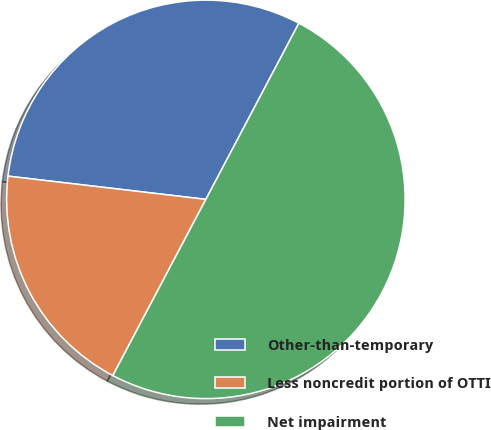Convert chart to OTSL. <chart><loc_0><loc_0><loc_500><loc_500><pie_chart><fcel>Other-than-temporary<fcel>Less noncredit portion of OTTI<fcel>Net impairment<nl><fcel>30.87%<fcel>19.13%<fcel>50.0%<nl></chart> 